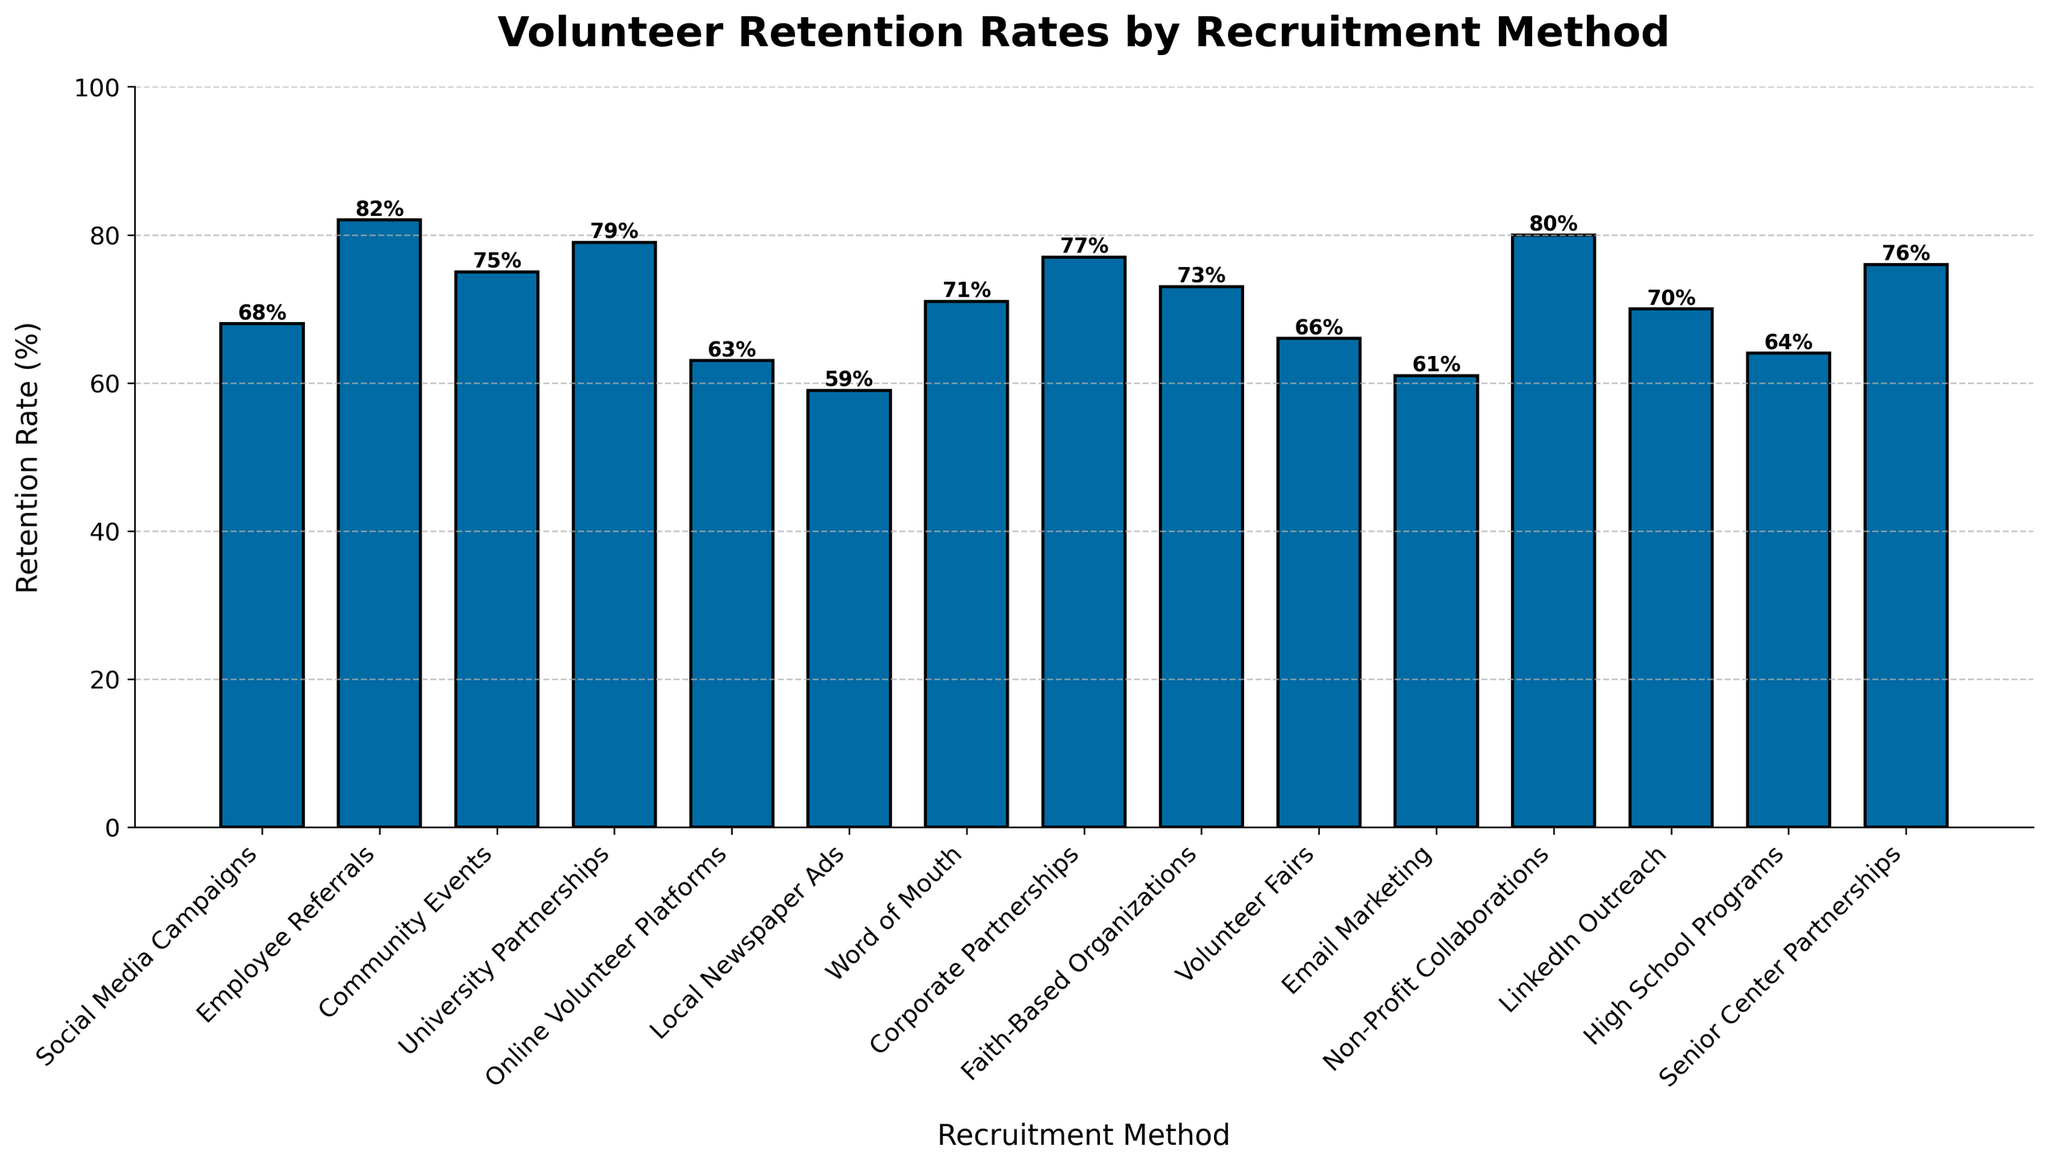Which recruitment method has the highest volunteer retention rate? Identify the bar with the greatest height, corresponding to "Employee Referrals" at 82%.
Answer: Employee Referrals What is the difference in retention rate between Social Media Campaigns and Local Newspaper Ads? Compare the heights of the bars for Social Media Campaigns (68%) and Local Newspaper Ads (59%), then compute the difference: 68% - 59% = 9%.
Answer: 9% Compare the retention rate of University Partnerships and Corporate Partnerships. Which is higher and by how much? Find the bars for University Partnerships (79%) and Corporate Partnerships (77%), then subtract the smaller percentage from the larger one: 79% - 77% = 2%. University Partnerships is higher.
Answer: University Partnerships by 2% What is the average retention rate of Social Media Campaigns, Employee Referrals, and Community Events? Sum the retention rates of these methods (68% + 82% + 75%) and divide by 3: (68 + 82 + 75) / 3 = 75%.
Answer: 75% What is the retention rate of the least effective recruitment method? Identify the shortest bar, which corresponds to "Local Newspaper Ads" at 59%.
Answer: 59% How many recruitment methods have a retention rate equal to or above 70%? Count the number of bars that reach or exceed the 70% mark: Employee Referrals, Community Events, University Partnerships, Corporate Partnerships, Faith-Based Organizations, Non-Profit Collaborations, LinkedIn Outreach, and Word of Mouth (8 methods).
Answer: 8 By how much does the retention rate of Volunteer Fairs exceed Email Marketing? Compare Volunteer Fairs (66%) to Email Marketing (61%) and calculate the difference: 66% - 61% = 5%.
Answer: 5% What is the combined retention rate of the top three recruitment methods? Sum the retention rates of Employee Referrals (82%), Non-Profit Collaborations (80%), and University Partnerships (79%): 82 + 80 + 79 = 241%.
Answer: 241% Is the retention rate of Senior Center Partnerships closer to that of Community Events or to Corporate Partnerships? Compare the differences: Community Events (75%) and Senior Center Partnerships (76%) have a difference of 1%; Corporate Partnerships (77%) and Senior Center Partnerships (76%) have a difference of 1%. Both are equally close.
Answer: Equally close Which recruitment methods have retention rates within 5% of 70%? Identify bars that fall within the range of 65% to 75%: Community Events (75%), LinkedIn Outreach (70%), Volunteer Fairs (66%), Social Media Campaigns (68%), and Faith-Based Organizations (73%).
Answer: Community Events, LinkedIn Outreach, Volunteer Fairs, Social Media Campaigns, Faith-Based Organizations 